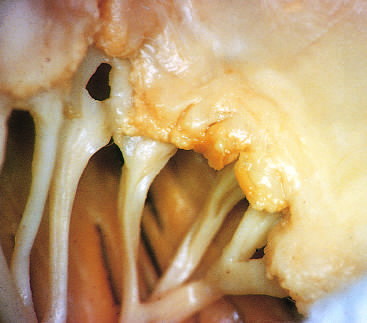s acute rheumatic mitral valvulitis superimposed on chronic rheumatic heart disease?
Answer the question using a single word or phrase. Yes 